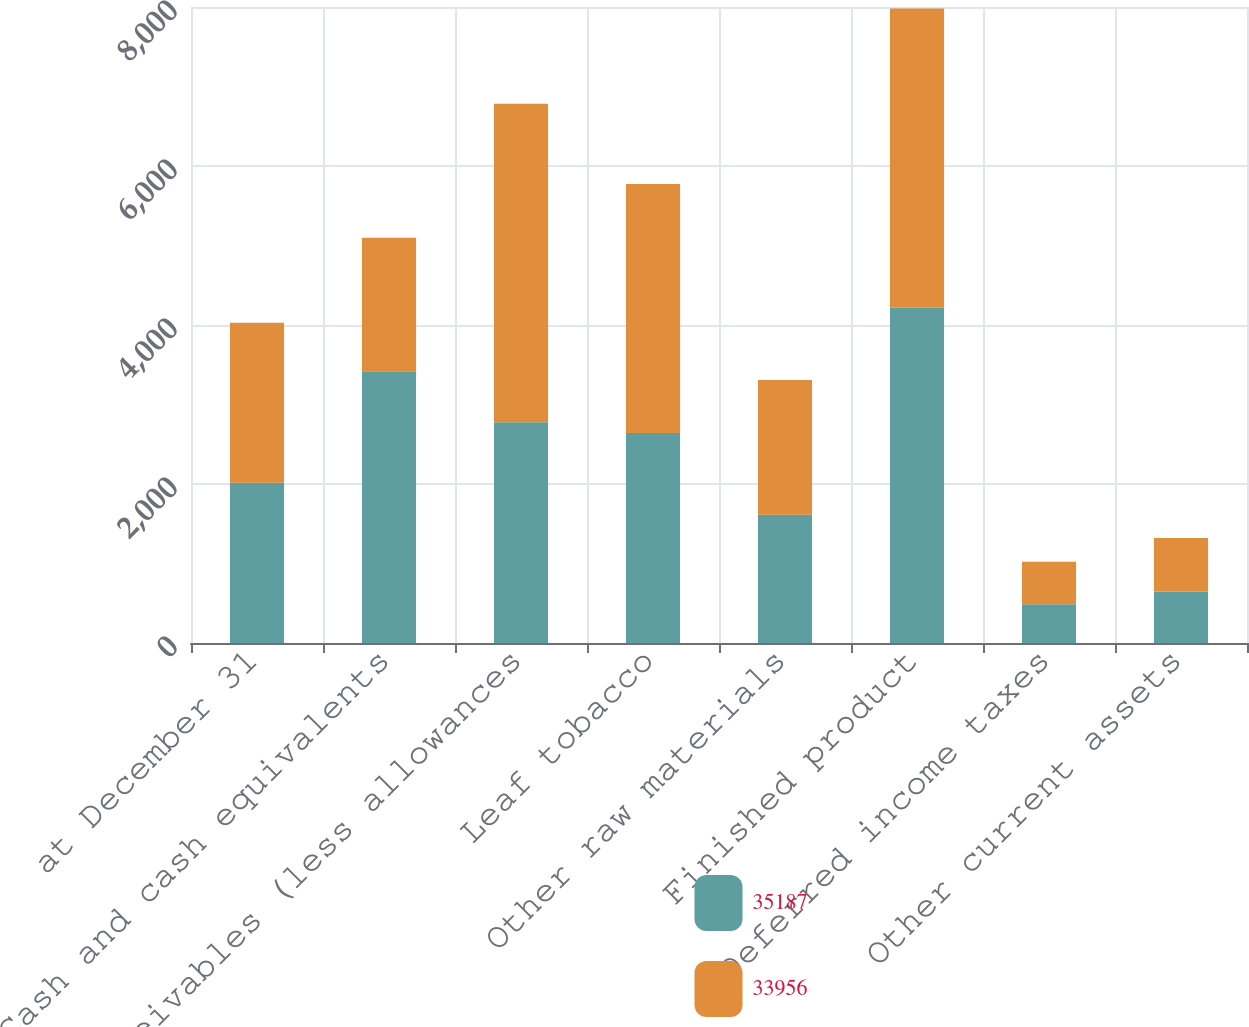<chart> <loc_0><loc_0><loc_500><loc_500><stacked_bar_chart><ecel><fcel>at December 31<fcel>Cash and cash equivalents<fcel>Receivables (less allowances<fcel>Leaf tobacco<fcel>Other raw materials<fcel>Finished product<fcel>Deferred income taxes<fcel>Other current assets<nl><fcel>35187<fcel>2015<fcel>3417<fcel>2778<fcel>2640<fcel>1613<fcel>4220<fcel>488<fcel>648<nl><fcel>33956<fcel>2014<fcel>1682<fcel>4004<fcel>3135<fcel>1696<fcel>3761<fcel>533<fcel>673<nl></chart> 